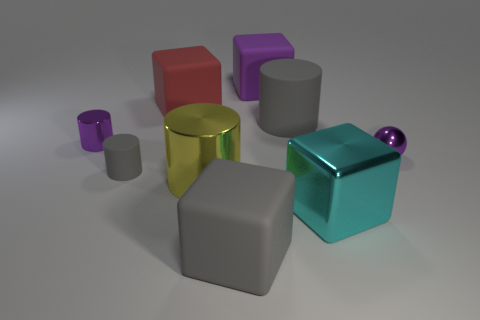Add 1 big yellow shiny things. How many objects exist? 10 Subtract all balls. How many objects are left? 8 Add 3 purple blocks. How many purple blocks exist? 4 Subtract 0 brown cylinders. How many objects are left? 9 Subtract all large gray blocks. Subtract all shiny cylinders. How many objects are left? 6 Add 3 cyan metal cubes. How many cyan metal cubes are left? 4 